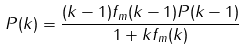Convert formula to latex. <formula><loc_0><loc_0><loc_500><loc_500>P ( k ) = \frac { ( k - 1 ) f _ { m } ( k - 1 ) P ( k - 1 ) } { 1 + k f _ { m } ( k ) }</formula> 